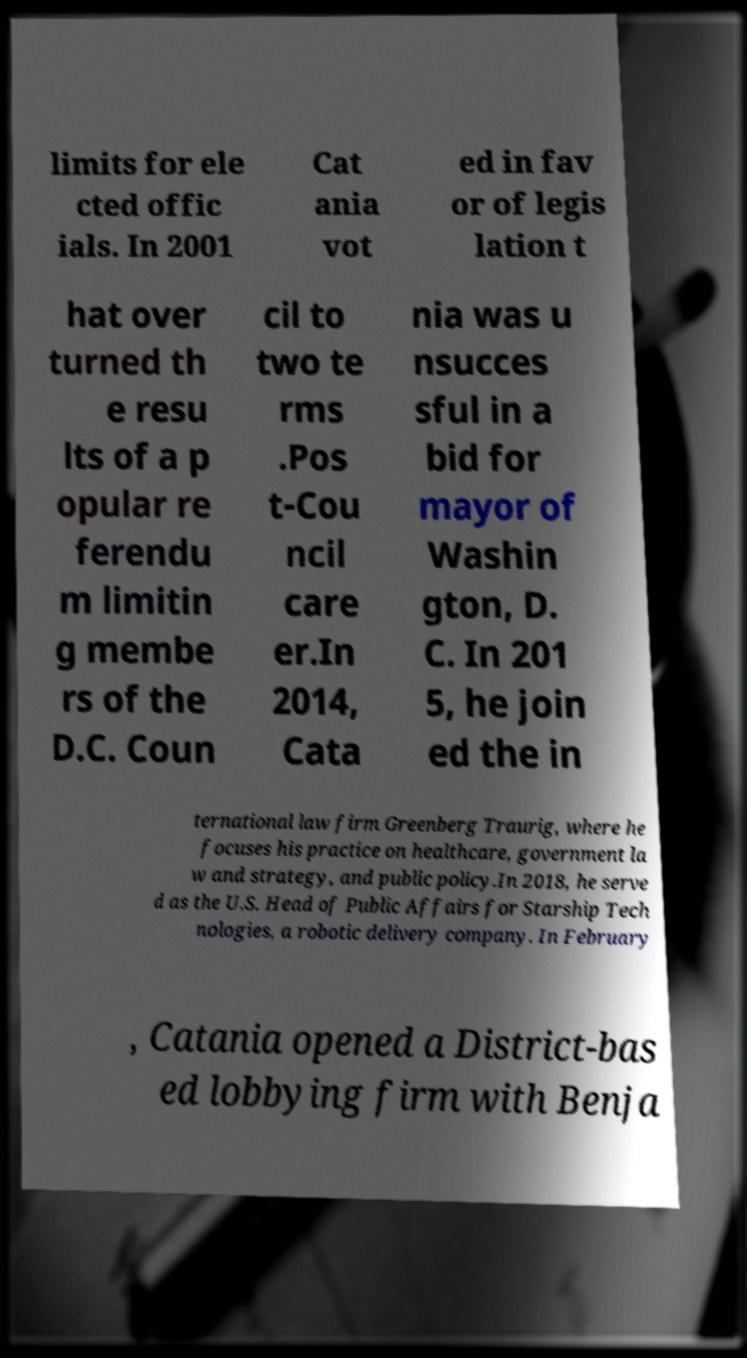Could you extract and type out the text from this image? limits for ele cted offic ials. In 2001 Cat ania vot ed in fav or of legis lation t hat over turned th e resu lts of a p opular re ferendu m limitin g membe rs of the D.C. Coun cil to two te rms .Pos t-Cou ncil care er.In 2014, Cata nia was u nsucces sful in a bid for mayor of Washin gton, D. C. In 201 5, he join ed the in ternational law firm Greenberg Traurig, where he focuses his practice on healthcare, government la w and strategy, and public policy.In 2018, he serve d as the U.S. Head of Public Affairs for Starship Tech nologies, a robotic delivery company. In February , Catania opened a District-bas ed lobbying firm with Benja 